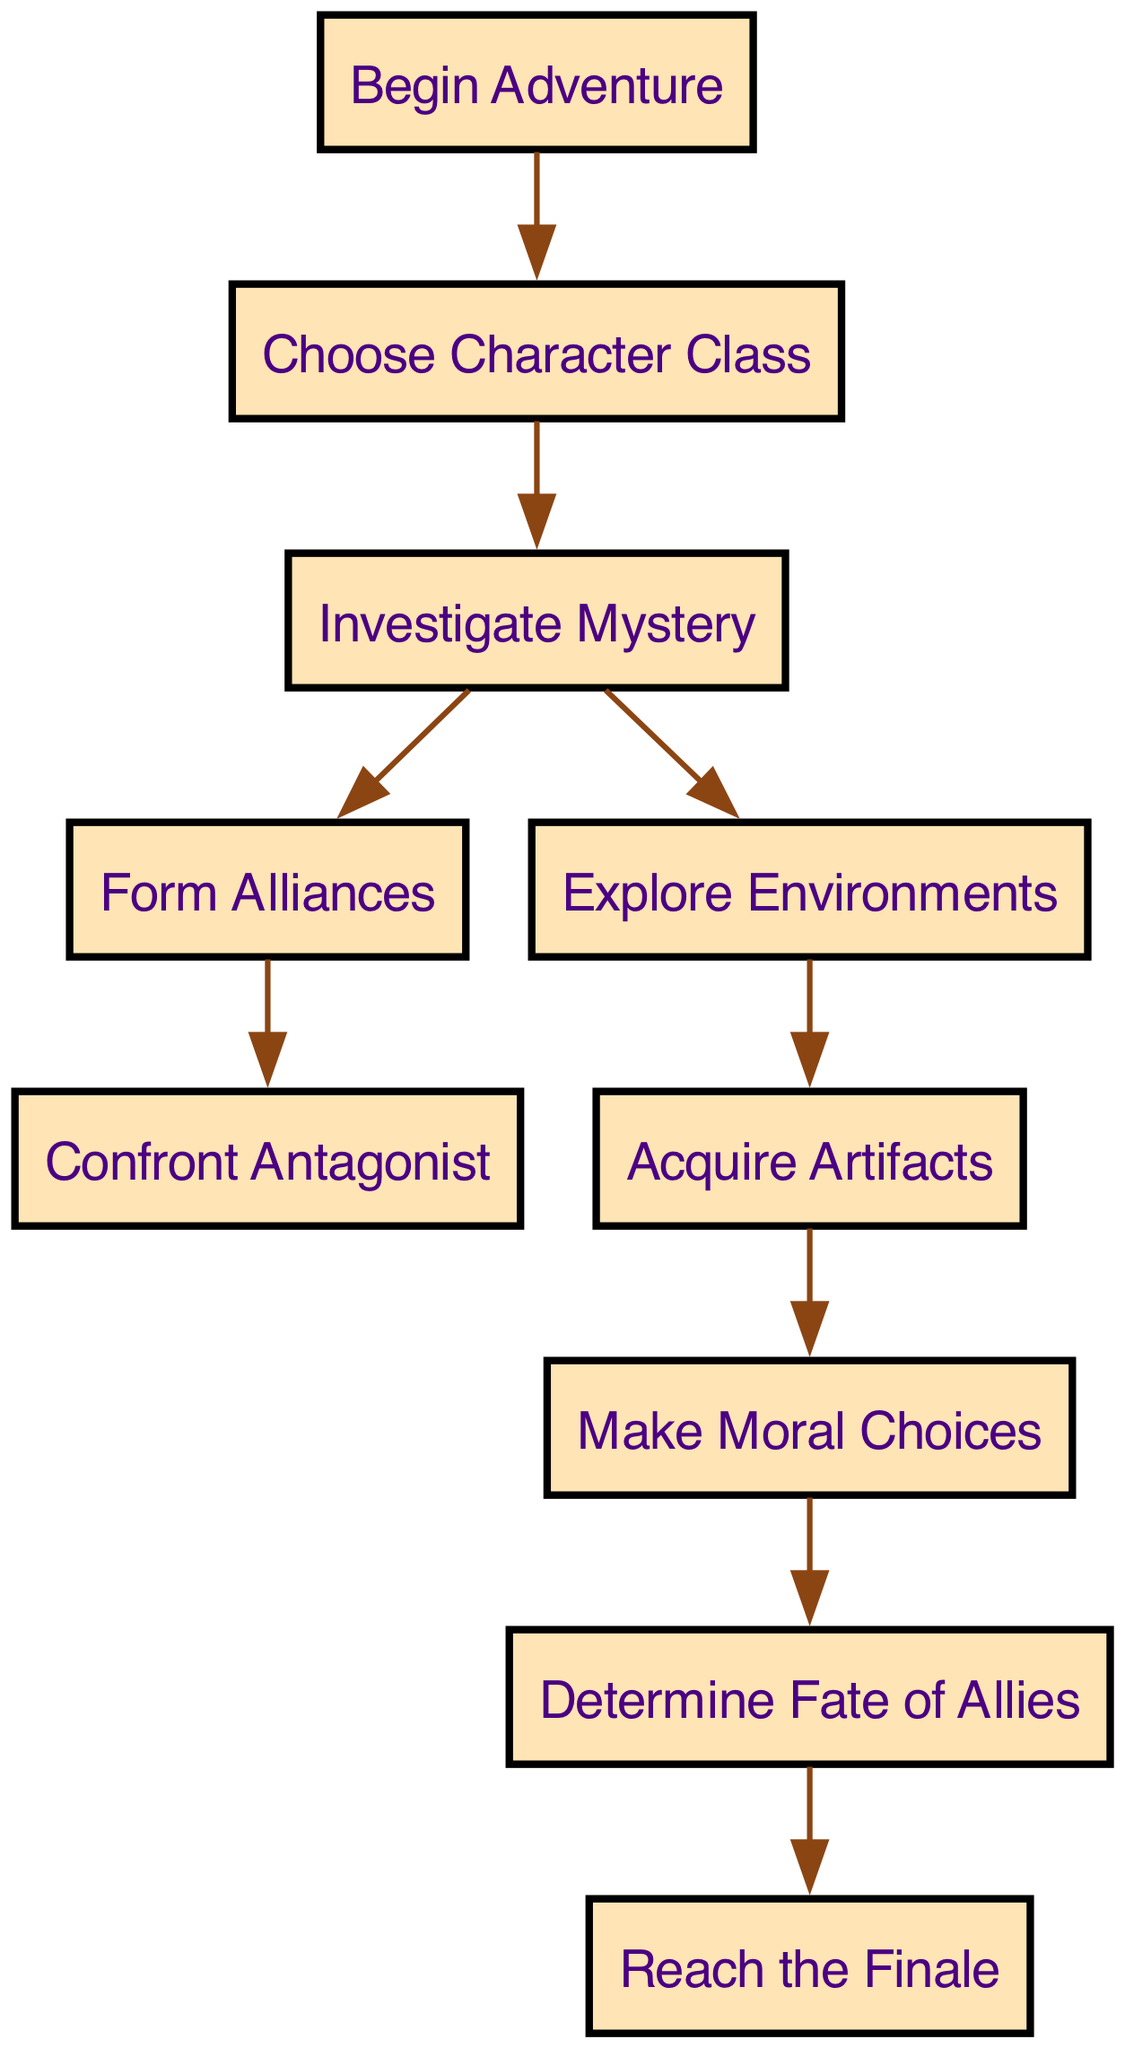What is the starting node in the diagram? The starting node is labeled "Begin Adventure", which is the first node in the flow of the directed graph.
Answer: Begin Adventure How many edges are there in total? By counting the directed connections between nodes based on the edges listed, there are 9 edges in total.
Answer: 9 Which node follows "Investigate Mystery"? The node that directly follows "Investigate Mystery" is "Form Alliances", as shown by the arrow leading from node 3 to node 4 in the diagram.
Answer: Form Alliances What are the two paths available after "Investigate Mystery"? After "Investigate Mystery", there are two paths: one leading to "Form Alliances" (node 4) and another leading to "Explore Environments" (node 6).
Answer: Form Alliances and Explore Environments What is the final node in the path? The final node, where the story concludes, is labeled "Reach the Finale" as it is the last node in the directed graph flow.
Answer: Reach the Finale Which node leads to "Confront Antagonist"? The node that leads to "Confront Antagonist" is "Form Alliances", indicated by the directed edge from node 4 to node 5 in the diagram.
Answer: Form Alliances What decision point comes after "Acquire Artifacts"? The decision point that comes after "Acquire Artifacts" is "Make Moral Choices", based on the directed connection from node 7 to node 8 in the graph.
Answer: Make Moral Choices How many nodes represent character interaction decisions? The nodes that represent character interaction decisions are "Choose Character Class", "Make Moral Choices", and "Determine Fate of Allies", totaling 3 nodes.
Answer: 3 